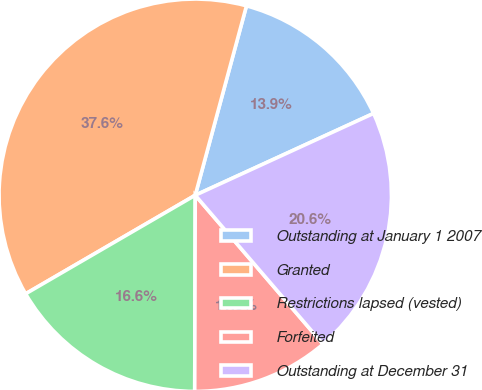<chart> <loc_0><loc_0><loc_500><loc_500><pie_chart><fcel>Outstanding at January 1 2007<fcel>Granted<fcel>Restrictions lapsed (vested)<fcel>Forfeited<fcel>Outstanding at December 31<nl><fcel>13.95%<fcel>37.58%<fcel>16.58%<fcel>11.33%<fcel>20.56%<nl></chart> 